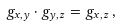Convert formula to latex. <formula><loc_0><loc_0><loc_500><loc_500>g _ { x , y } \cdot g _ { y , z } = g _ { x , z } \, ,</formula> 